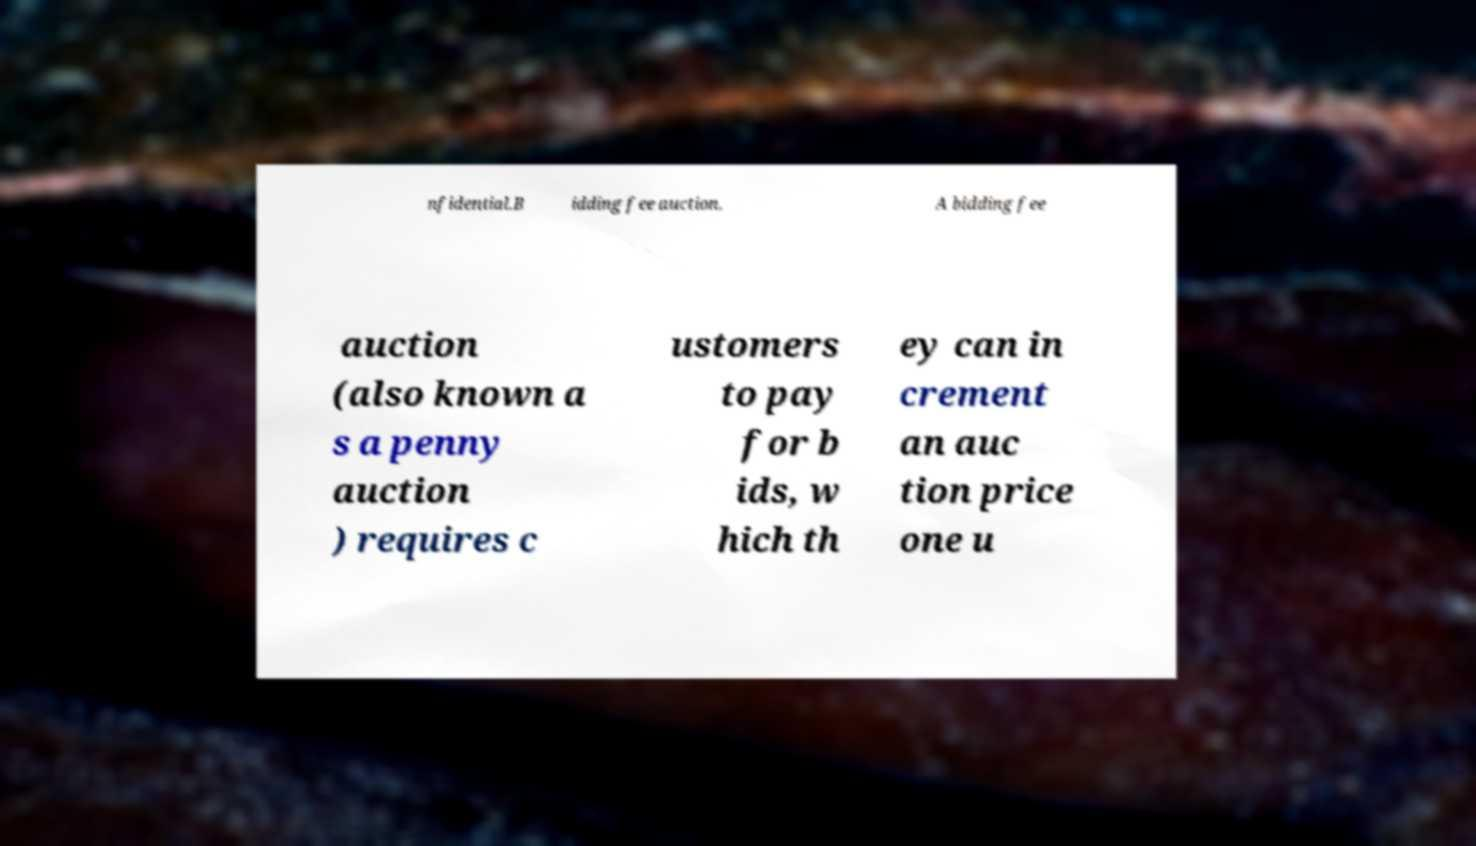I need the written content from this picture converted into text. Can you do that? nfidential.B idding fee auction. A bidding fee auction (also known a s a penny auction ) requires c ustomers to pay for b ids, w hich th ey can in crement an auc tion price one u 